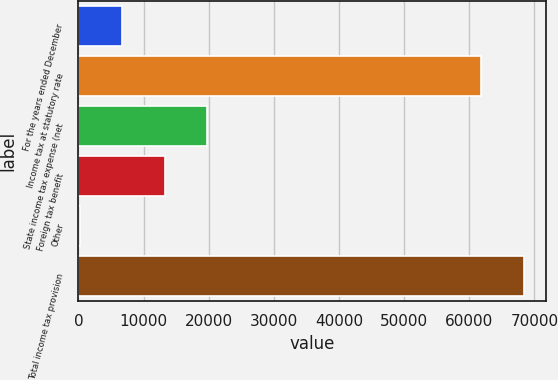Convert chart. <chart><loc_0><loc_0><loc_500><loc_500><bar_chart><fcel>For the years ended December<fcel>Income tax at statutory rate<fcel>State income tax expense (net<fcel>Foreign tax benefit<fcel>Other<fcel>Total income tax provision<nl><fcel>6720<fcel>61825<fcel>19740<fcel>13230<fcel>210<fcel>68335<nl></chart> 